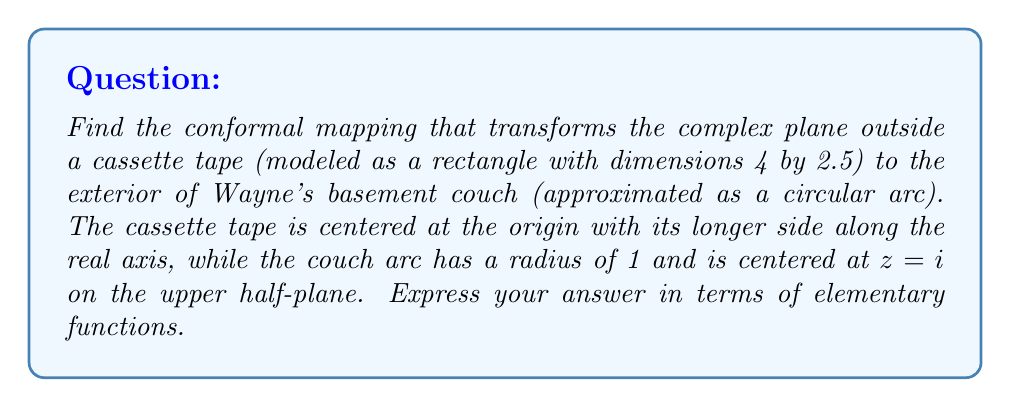Show me your answer to this math problem. Let's approach this step-by-step:

1) First, we need to map the exterior of the rectangle to the exterior of the unit circle. This can be done using the Schwarz-Christoffel transformation. However, it's a complex process, so we'll use a known result: the mapping from the exterior of a rectangle to the exterior of the unit circle is given by the Jacobi elliptic function $\text{sn}(z,k)$, where $k$ is the modulus determined by the rectangle's dimensions.

2) For a rectangle with dimensions $a$ and $b$ (where $a > b$), the modulus $k$ is given by:

   $$k = \frac{\sqrt{a^2-b^2}}{a}$$

   In our case, $a=4$ and $b=2.5$, so:

   $$k = \frac{\sqrt{4^2-2.5^2}}{4} = \frac{\sqrt{9.75}}{4} \approx 0.7795$$

3) The mapping function from the exterior of the rectangle to the exterior of the unit circle is:

   $$w_1 = \text{sn}(\frac{2K}{\pi}z, k)$$

   where $K$ is the complete elliptic integral of the first kind with modulus $k$.

4) Next, we need to map the exterior of the unit circle to the exterior of the circular arc. This can be done using a Möbius transformation:

   $$w_2 = \frac{w_1-i}{iw_1+1}$$

5) Composing these two transformations gives us the desired mapping:

   $$w = \frac{\text{sn}(\frac{2K}{\pi}z, k)-i}{i\text{sn}(\frac{2K}{\pi}z, k)+1}$$

This maps the exterior of the cassette tape to the exterior of Wayne's couch.
Answer: $$w = \frac{\text{sn}(\frac{2K}{\pi}z, k)-i}{i\text{sn}(\frac{2K}{\pi}z, k)+1}$$
where $k \approx 0.7795$ and $K$ is the complete elliptic integral of the first kind with modulus $k$. 